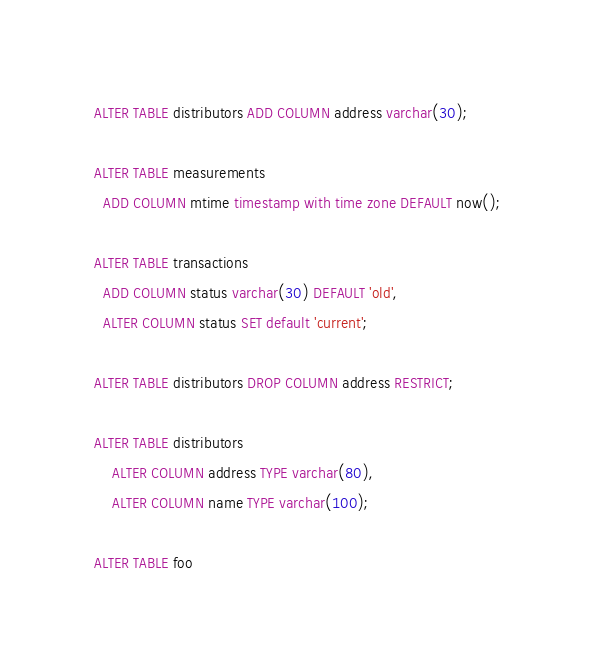Convert code to text. <code><loc_0><loc_0><loc_500><loc_500><_SQL_>ALTER TABLE distributors ADD COLUMN address varchar(30);

ALTER TABLE measurements
  ADD COLUMN mtime timestamp with time zone DEFAULT now();

ALTER TABLE transactions
  ADD COLUMN status varchar(30) DEFAULT 'old',
  ALTER COLUMN status SET default 'current';

ALTER TABLE distributors DROP COLUMN address RESTRICT;

ALTER TABLE distributors
    ALTER COLUMN address TYPE varchar(80),
    ALTER COLUMN name TYPE varchar(100);

ALTER TABLE foo</code> 